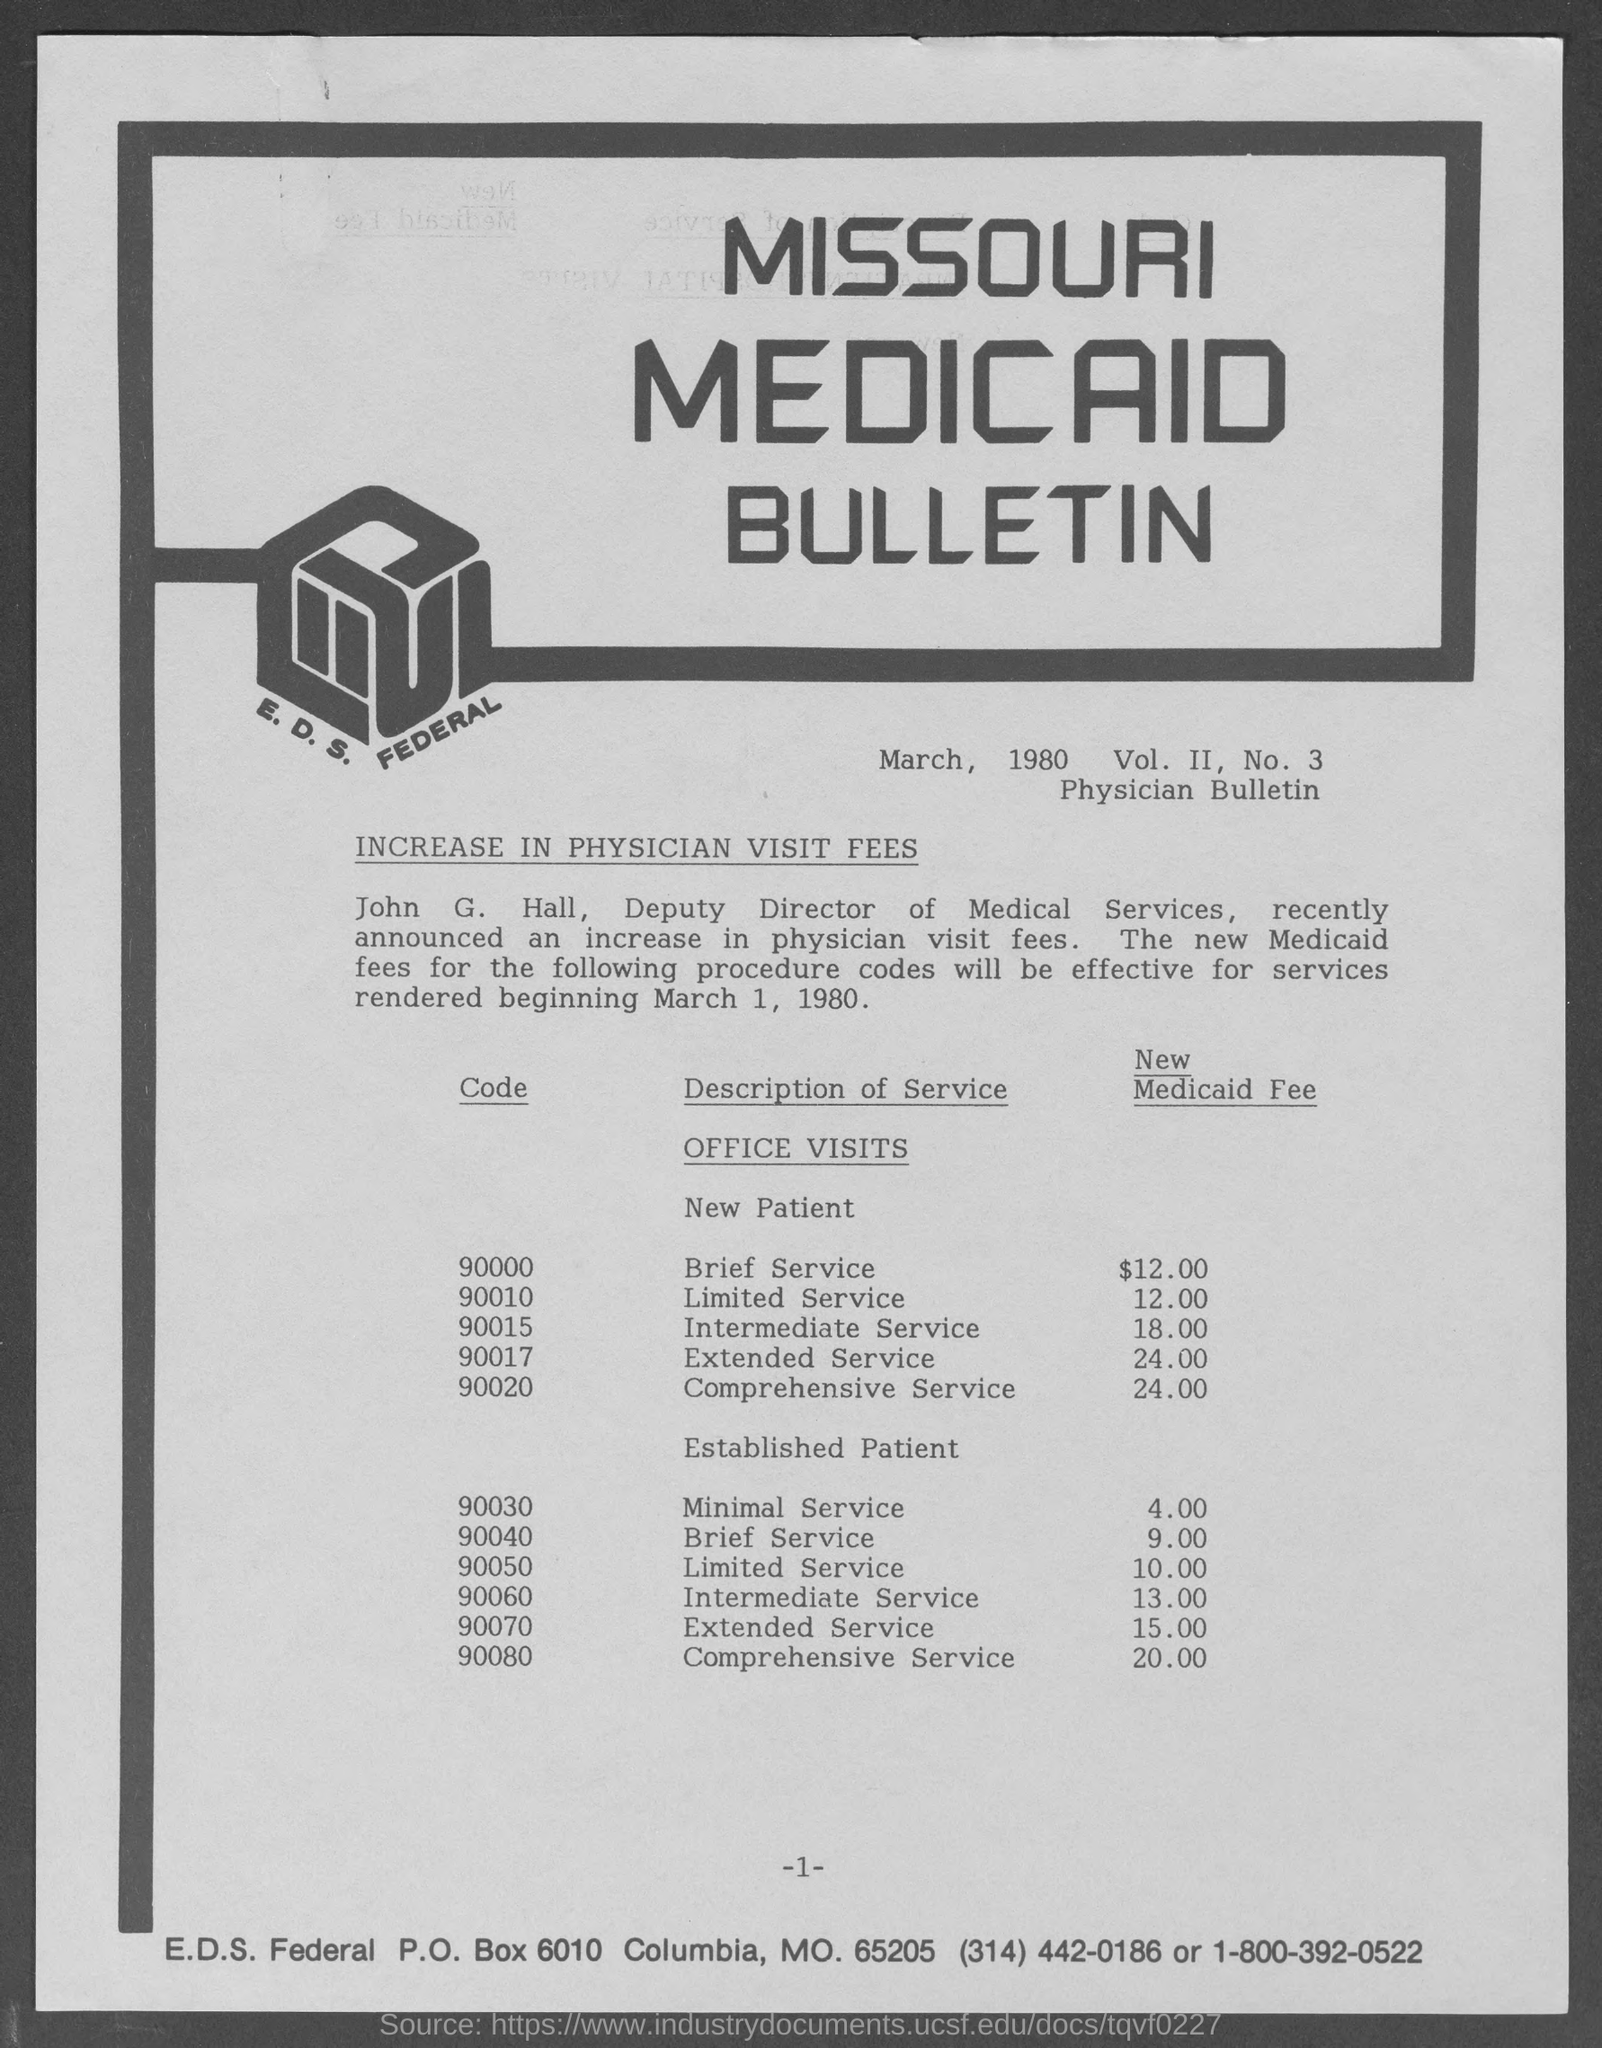What is the heading mentioned in the given page ?
Provide a short and direct response. Missouri medicaid bulletin. What is the code given for brief service for new patient in the given table ?
Provide a short and direct response. 90000. What is the new medicaid fee for limited service of new patient ?
Your response must be concise. $ 12.00. What is the new medicaid fee for intermediate service of new patient ?
Your answer should be compact. 18.00. What is the new medicaid fee for extended service of new patient ?
Make the answer very short. 24.00. What is the new medicaid fee for comprehensive service of new patient ?
Ensure brevity in your answer.  24.00. What is the new medicaid fee for comprehensive service of established patient ?
Your answer should be very brief. 20.00. What is the new medicaid fee for minimal service of established patient ?
Give a very brief answer. 4.00. What is the new medicaid fee for brief  service of established patient ?
Your response must be concise. 9.00. What is the new medicaid fee for intermediate  service of established patient ?
Keep it short and to the point. 13.00. 